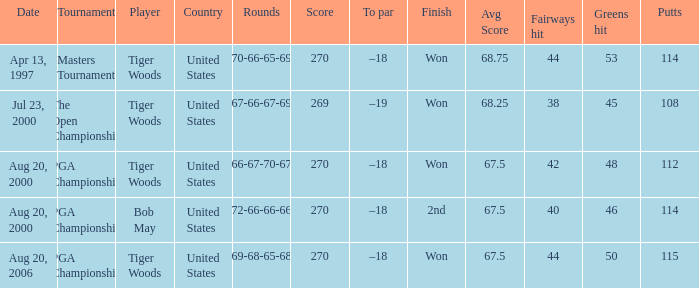What days were the rounds of 66-67-70-67 recorded? Aug 20, 2000. 